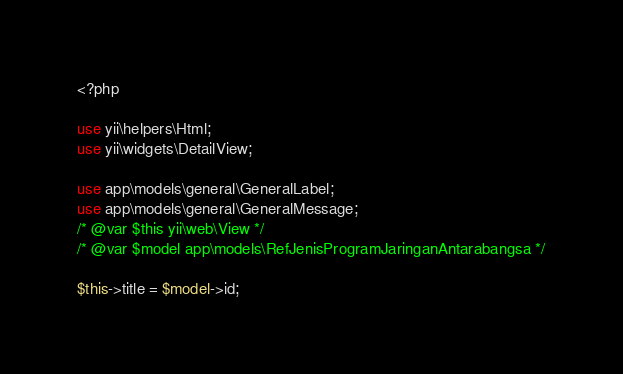Convert code to text. <code><loc_0><loc_0><loc_500><loc_500><_PHP_><?php

use yii\helpers\Html;
use yii\widgets\DetailView;

use app\models\general\GeneralLabel;
use app\models\general\GeneralMessage;
/* @var $this yii\web\View */
/* @var $model app\models\RefJenisProgramJaringanAntarabangsa */

$this->title = $model->id;</code> 